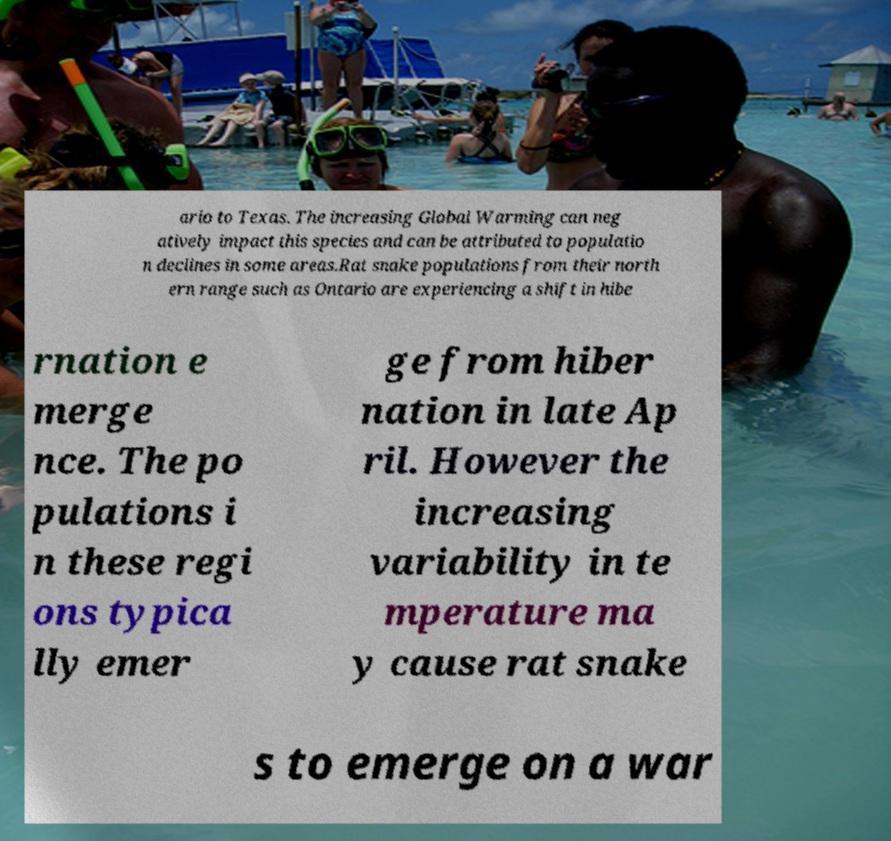Can you read and provide the text displayed in the image?This photo seems to have some interesting text. Can you extract and type it out for me? ario to Texas. The increasing Global Warming can neg atively impact this species and can be attributed to populatio n declines in some areas.Rat snake populations from their north ern range such as Ontario are experiencing a shift in hibe rnation e merge nce. The po pulations i n these regi ons typica lly emer ge from hiber nation in late Ap ril. However the increasing variability in te mperature ma y cause rat snake s to emerge on a war 